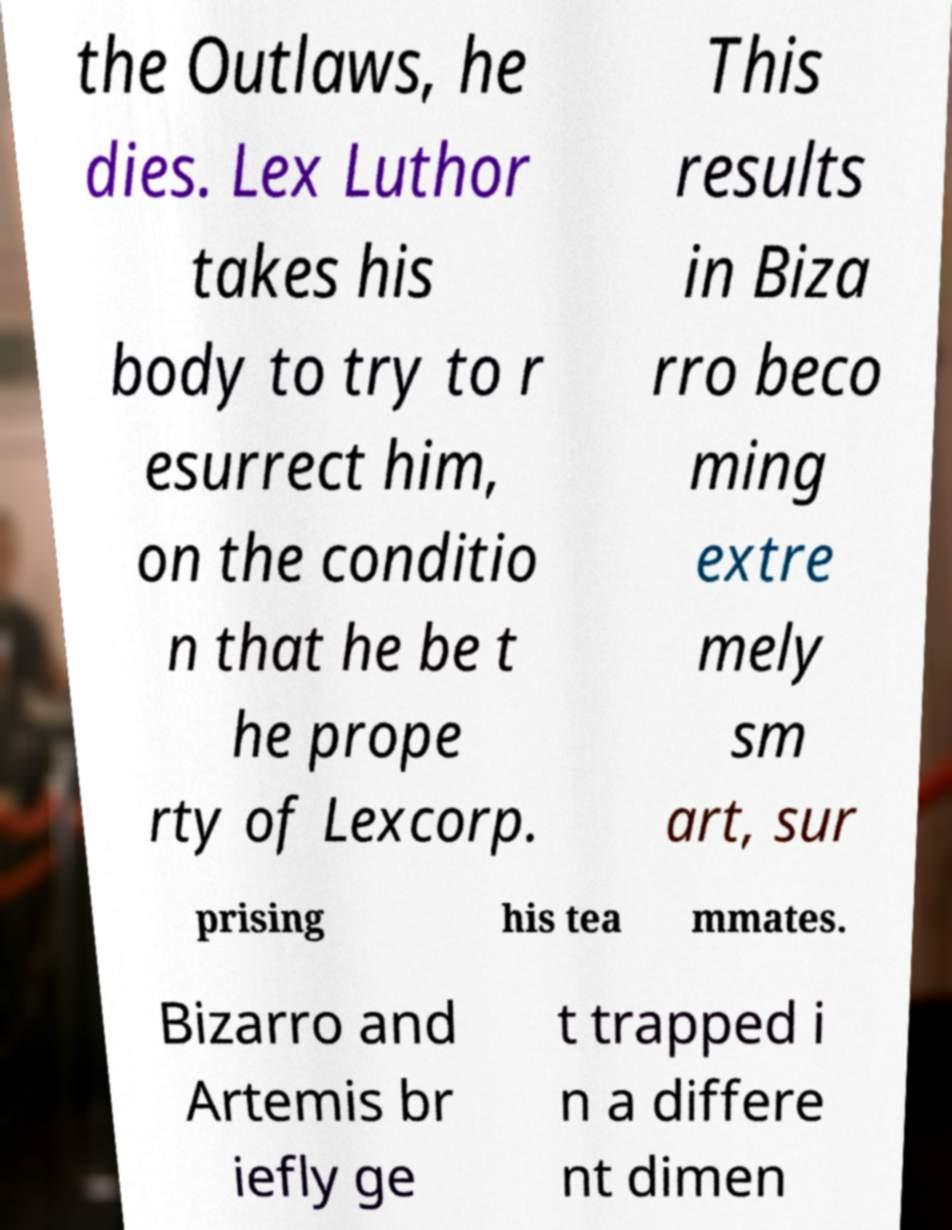For documentation purposes, I need the text within this image transcribed. Could you provide that? the Outlaws, he dies. Lex Luthor takes his body to try to r esurrect him, on the conditio n that he be t he prope rty of Lexcorp. This results in Biza rro beco ming extre mely sm art, sur prising his tea mmates. Bizarro and Artemis br iefly ge t trapped i n a differe nt dimen 